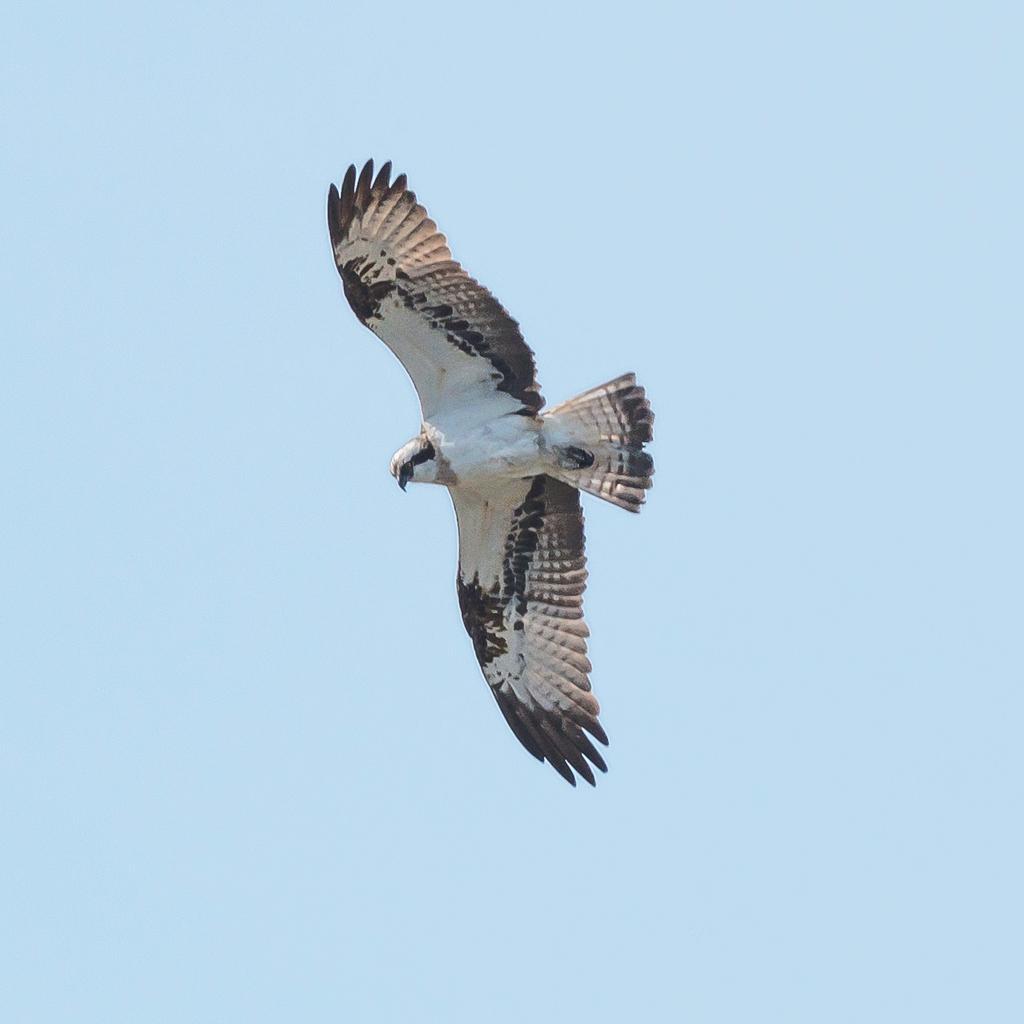Describe this image in one or two sentences. In this image, I can see a bird flying. I think this is an eagle. The background looks light blue in color. 